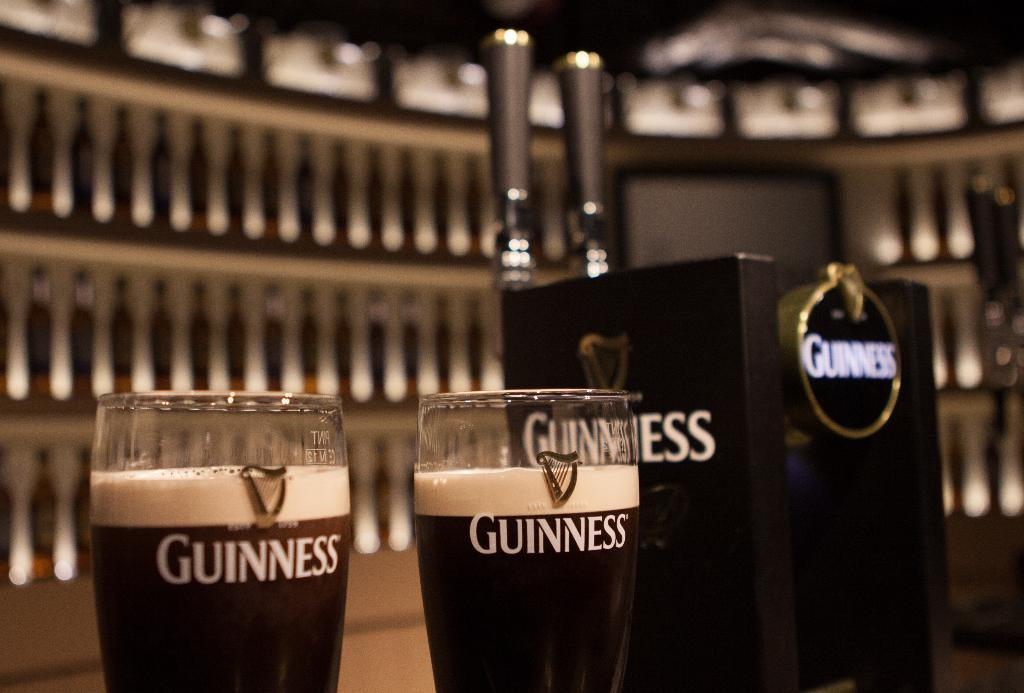<image>
Give a short and clear explanation of the subsequent image. 2 glasses with Guinness next to a beer stand 